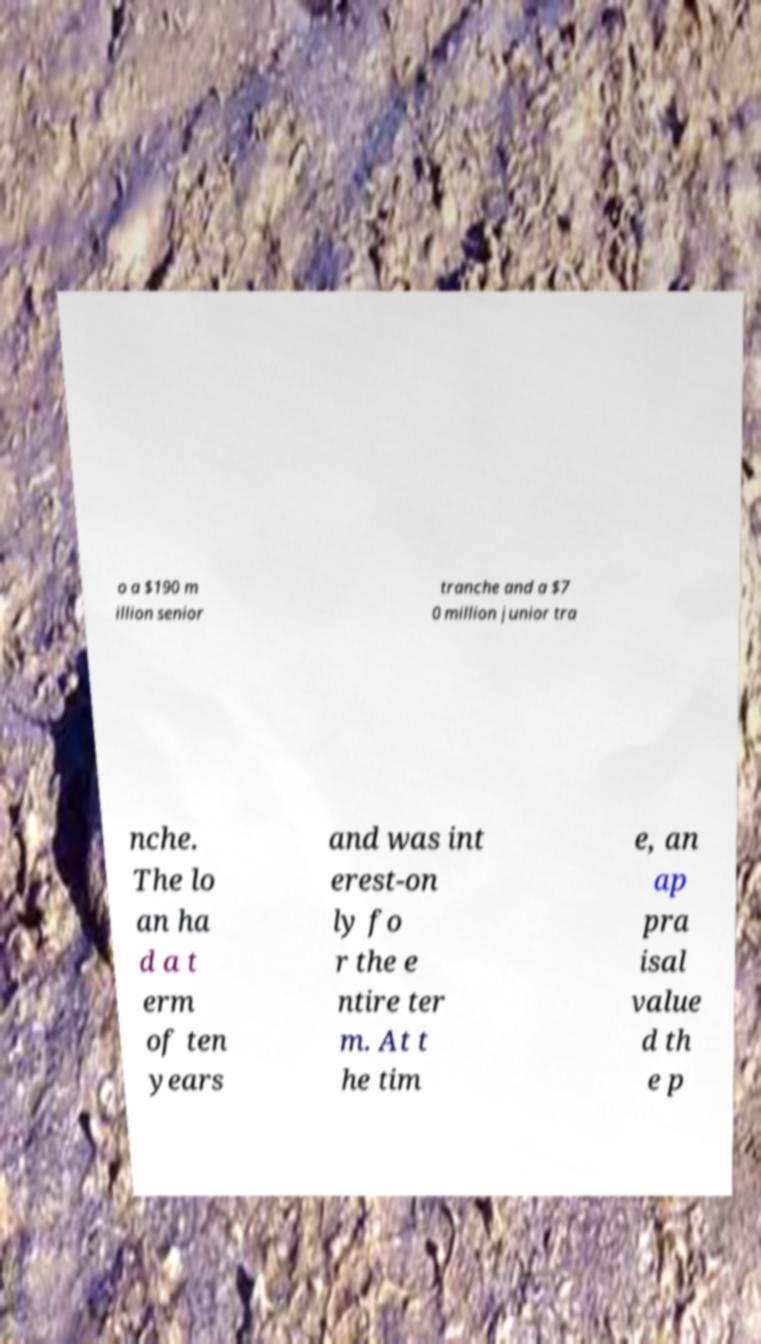Could you assist in decoding the text presented in this image and type it out clearly? o a $190 m illion senior tranche and a $7 0 million junior tra nche. The lo an ha d a t erm of ten years and was int erest-on ly fo r the e ntire ter m. At t he tim e, an ap pra isal value d th e p 